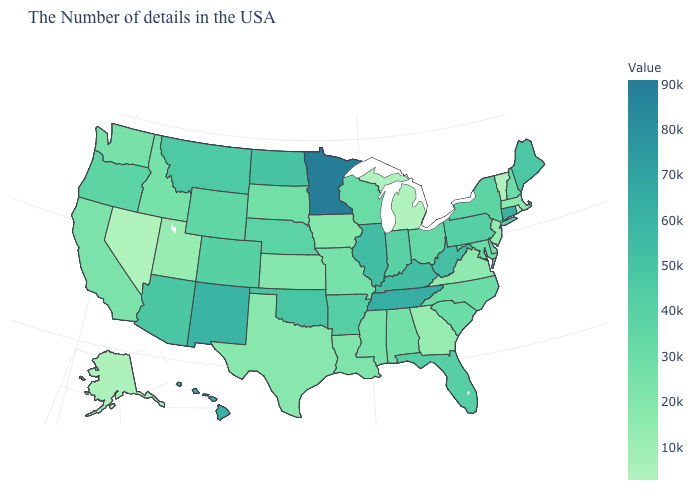Which states hav the highest value in the MidWest?
Give a very brief answer. Minnesota. Does the map have missing data?
Be succinct. No. Which states have the highest value in the USA?
Keep it brief. Minnesota. Is the legend a continuous bar?
Answer briefly. Yes. Does Iowa have a lower value than Nevada?
Keep it brief. No. Does the map have missing data?
Keep it brief. No. 